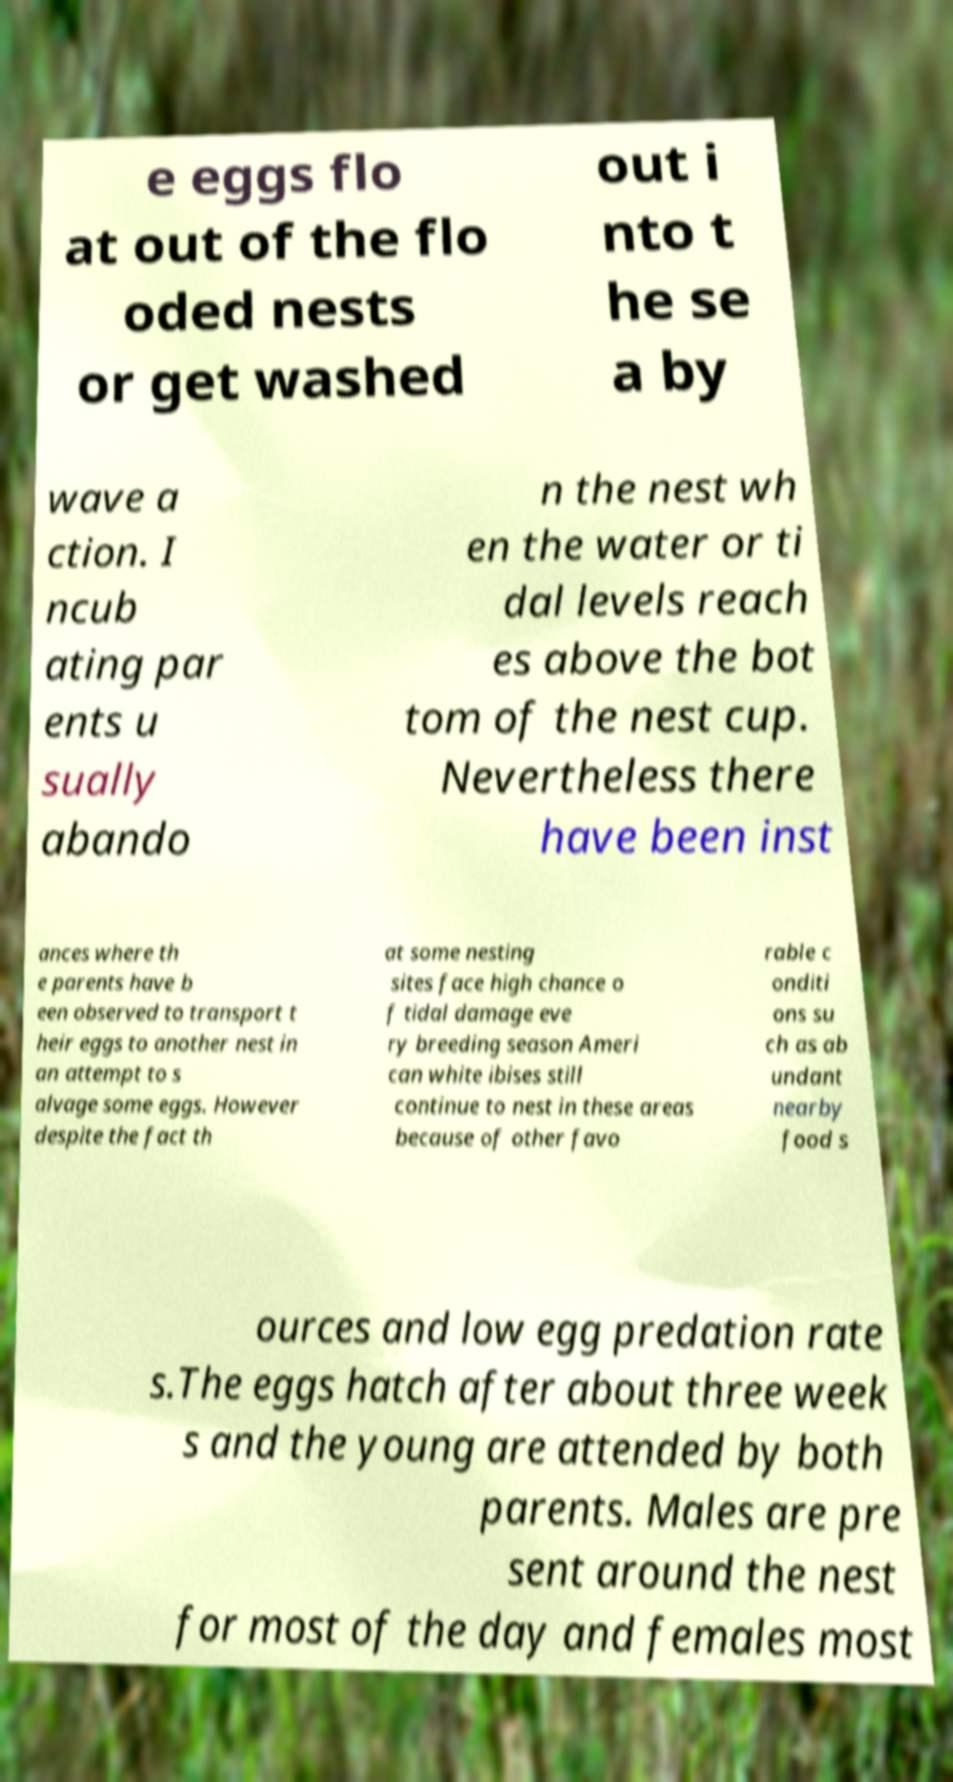Can you read and provide the text displayed in the image?This photo seems to have some interesting text. Can you extract and type it out for me? e eggs flo at out of the flo oded nests or get washed out i nto t he se a by wave a ction. I ncub ating par ents u sually abando n the nest wh en the water or ti dal levels reach es above the bot tom of the nest cup. Nevertheless there have been inst ances where th e parents have b een observed to transport t heir eggs to another nest in an attempt to s alvage some eggs. However despite the fact th at some nesting sites face high chance o f tidal damage eve ry breeding season Ameri can white ibises still continue to nest in these areas because of other favo rable c onditi ons su ch as ab undant nearby food s ources and low egg predation rate s.The eggs hatch after about three week s and the young are attended by both parents. Males are pre sent around the nest for most of the day and females most 